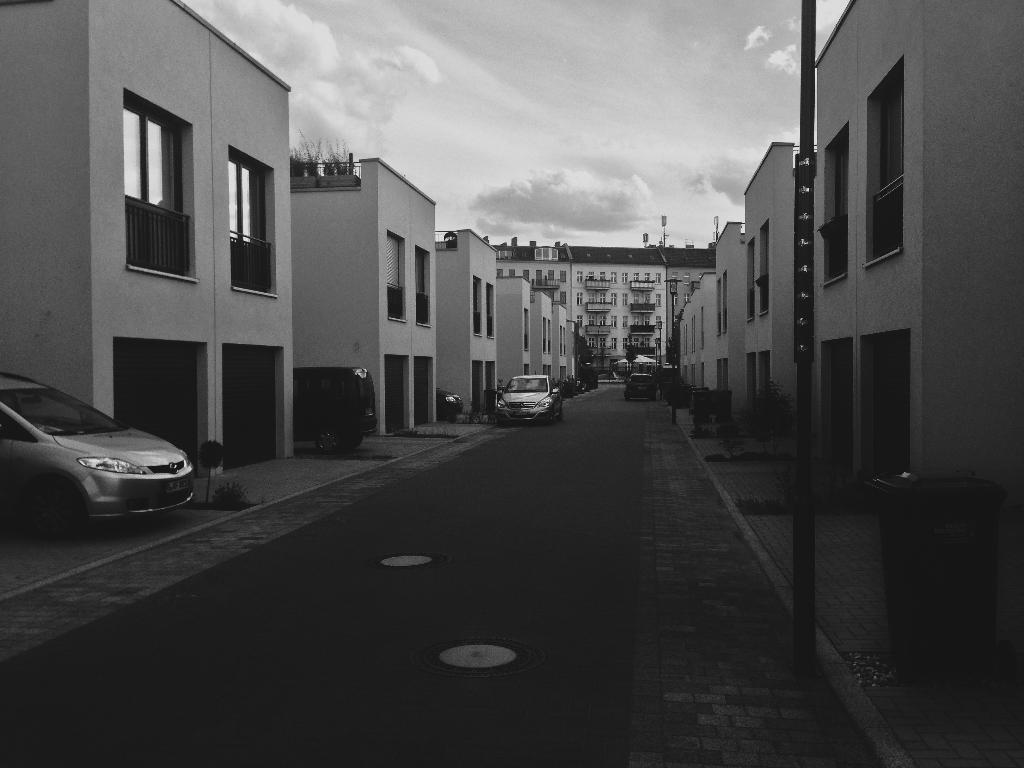How would you summarize this image in a sentence or two? In the middle of the image we can see some poles, plants, trees and vehicles on the road. Behind them we can see some buildings. At the top of the image we can see some clouds in the sky. In the bottom right corner of the image we can see a dustbin. 